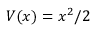Convert formula to latex. <formula><loc_0><loc_0><loc_500><loc_500>V ( x ) = x ^ { 2 } / 2</formula> 